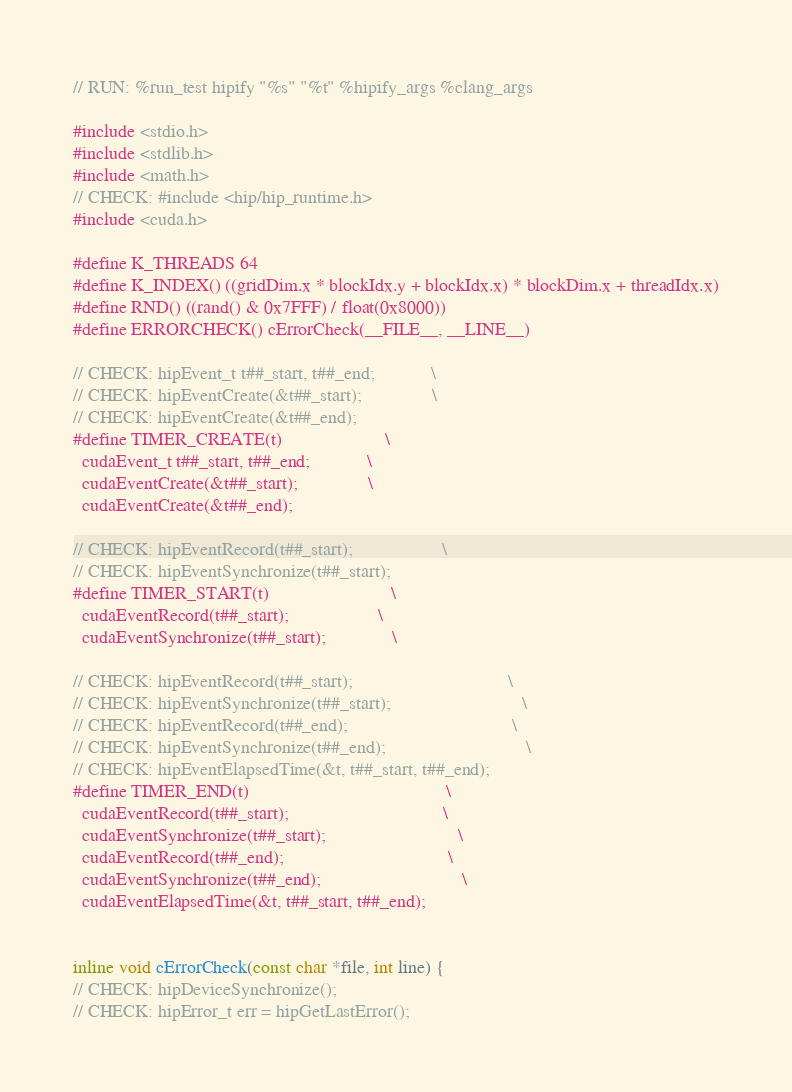Convert code to text. <code><loc_0><loc_0><loc_500><loc_500><_Cuda_>// RUN: %run_test hipify "%s" "%t" %hipify_args %clang_args

#include <stdio.h>
#include <stdlib.h>
#include <math.h>
// CHECK: #include <hip/hip_runtime.h>
#include <cuda.h>

#define K_THREADS 64
#define K_INDEX() ((gridDim.x * blockIdx.y + blockIdx.x) * blockDim.x + threadIdx.x)
#define RND() ((rand() & 0x7FFF) / float(0x8000))
#define ERRORCHECK() cErrorCheck(__FILE__, __LINE__)

// CHECK: hipEvent_t t##_start, t##_end;            \
// CHECK: hipEventCreate(&t##_start);               \
// CHECK: hipEventCreate(&t##_end);
#define TIMER_CREATE(t)                      \
  cudaEvent_t t##_start, t##_end;            \
  cudaEventCreate(&t##_start);               \
  cudaEventCreate(&t##_end);

// CHECK: hipEventRecord(t##_start);                   \
// CHECK: hipEventSynchronize(t##_start);
#define TIMER_START(t)                          \
  cudaEventRecord(t##_start);                   \
  cudaEventSynchronize(t##_start);              \

// CHECK: hipEventRecord(t##_start);                                 \
// CHECK: hipEventSynchronize(t##_start);                            \
// CHECK: hipEventRecord(t##_end);                                   \
// CHECK: hipEventSynchronize(t##_end);                              \
// CHECK: hipEventElapsedTime(&t, t##_start, t##_end);
#define TIMER_END(t)                                          \
  cudaEventRecord(t##_start);                                 \
  cudaEventSynchronize(t##_start);                            \
  cudaEventRecord(t##_end);                                   \
  cudaEventSynchronize(t##_end);                              \
  cudaEventElapsedTime(&t, t##_start, t##_end);               


inline void cErrorCheck(const char *file, int line) {
// CHECK: hipDeviceSynchronize();
// CHECK: hipError_t err = hipGetLastError();</code> 